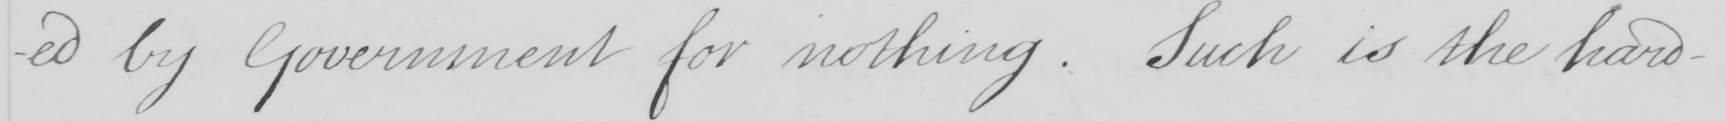What is written in this line of handwriting? -ed by Government for nothing . Such is the hard- 